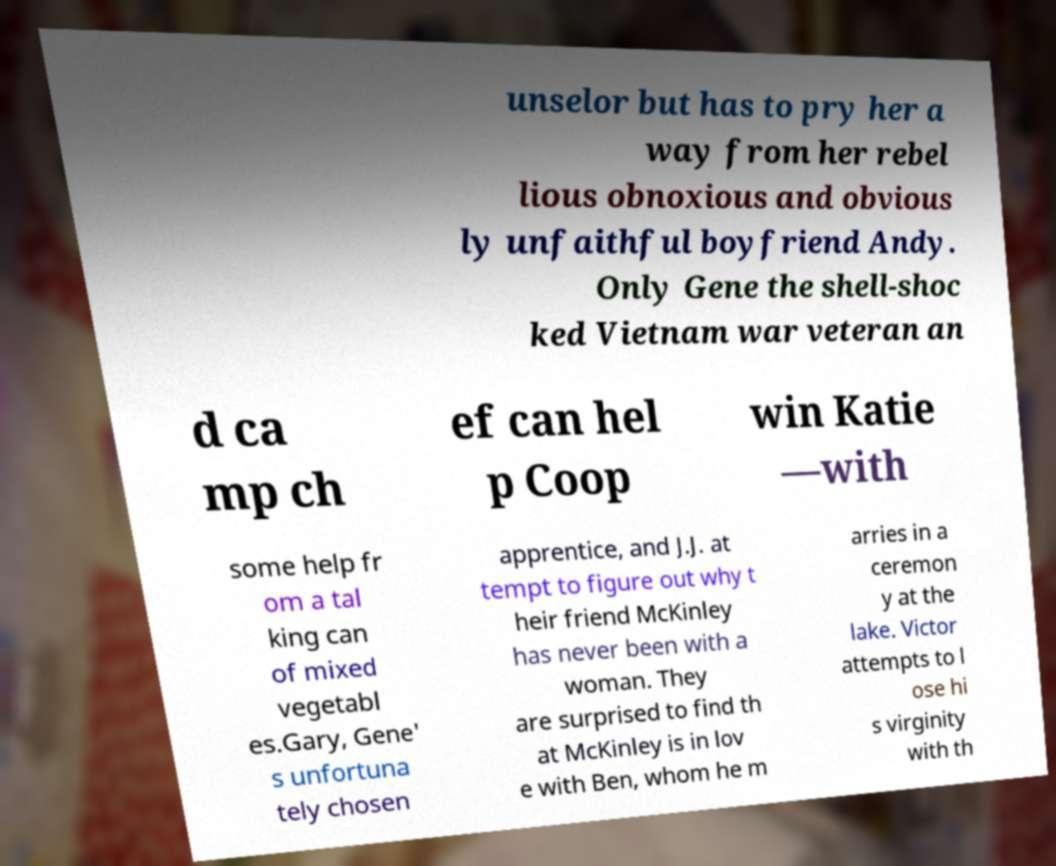Could you extract and type out the text from this image? unselor but has to pry her a way from her rebel lious obnoxious and obvious ly unfaithful boyfriend Andy. Only Gene the shell-shoc ked Vietnam war veteran an d ca mp ch ef can hel p Coop win Katie —with some help fr om a tal king can of mixed vegetabl es.Gary, Gene' s unfortuna tely chosen apprentice, and J.J. at tempt to figure out why t heir friend McKinley has never been with a woman. They are surprised to find th at McKinley is in lov e with Ben, whom he m arries in a ceremon y at the lake. Victor attempts to l ose hi s virginity with th 